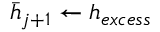<formula> <loc_0><loc_0><loc_500><loc_500>\bar { h } _ { j + 1 } \leftarrow h _ { e x c e s s }</formula> 